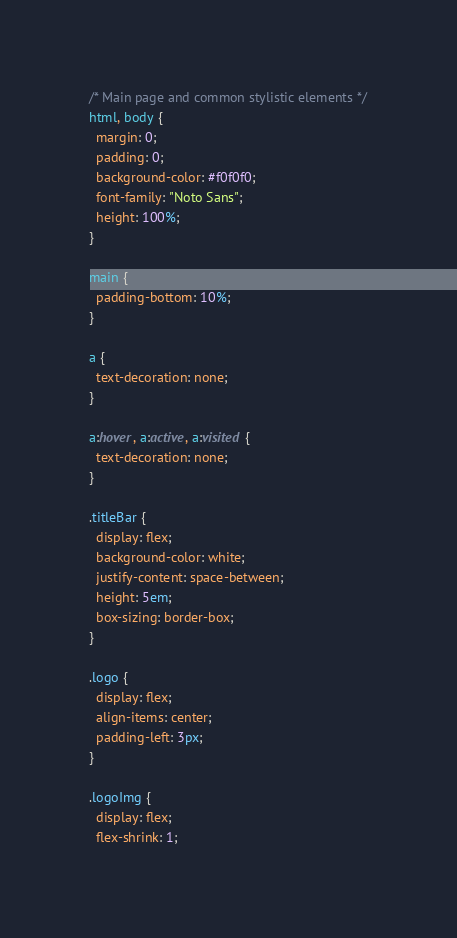Convert code to text. <code><loc_0><loc_0><loc_500><loc_500><_CSS_>/* Main page and common stylistic elements */
html, body {
  margin: 0;
  padding: 0;
  background-color: #f0f0f0;
  font-family: "Noto Sans";
  height: 100%;
}

main {
  padding-bottom: 10%;
}

a {
  text-decoration: none;
}

a:hover, a:active, a:visited {
  text-decoration: none;
}

.titleBar {
  display: flex;
  background-color: white;
  justify-content: space-between;
  height: 5em;
  box-sizing: border-box;
}

.logo {
  display: flex;
  align-items: center;
  padding-left: 3px;
}

.logoImg {
  display: flex;
  flex-shrink: 1;</code> 